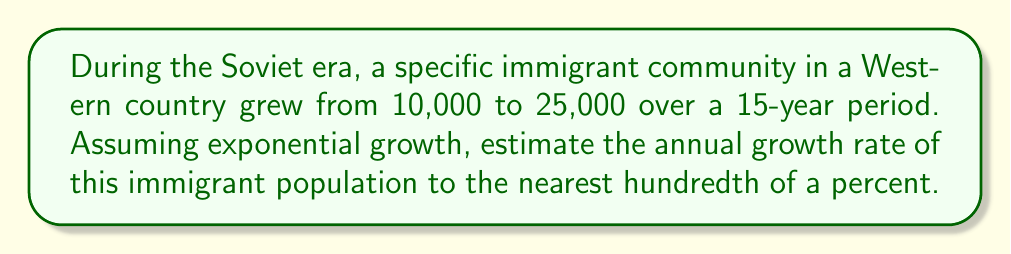What is the answer to this math problem? To solve this problem, we'll use the exponential growth model:

$$P(t) = P_0 e^{rt}$$

Where:
$P(t)$ is the population at time $t$
$P_0$ is the initial population
$r$ is the annual growth rate
$t$ is the time in years

Given:
$P_0 = 10,000$
$P(15) = 25,000$
$t = 15$ years

Step 1: Substitute the known values into the exponential growth equation:
$$25,000 = 10,000 e^{15r}$$

Step 2: Divide both sides by 10,000:
$$2.5 = e^{15r}$$

Step 3: Take the natural logarithm of both sides:
$$\ln(2.5) = 15r$$

Step 4: Solve for $r$:
$$r = \frac{\ln(2.5)}{15}$$

Step 5: Calculate the value of $r$:
$$r = \frac{0.9162907318741551}{15} \approx 0.0610860488$$

Step 6: Convert $r$ to a percentage:
$$r \approx 0.0610860488 \times 100\% \approx 6.11\%$$

Therefore, the estimated annual growth rate is approximately 6.11%.
Answer: 6.11% 